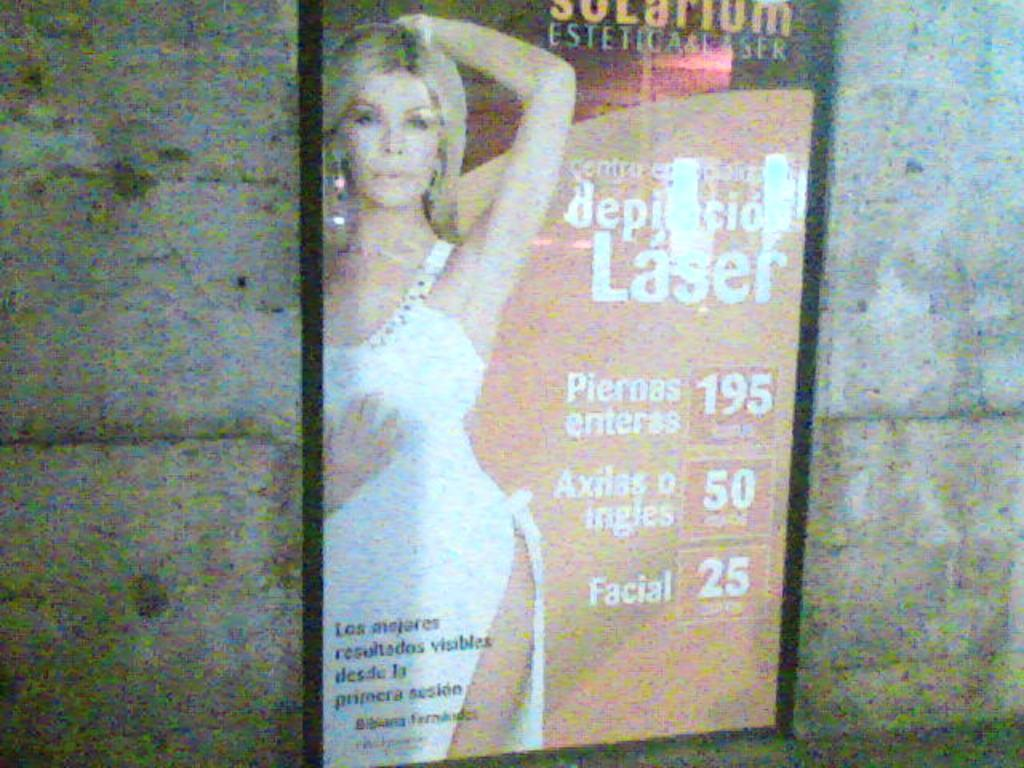What is the main subject in the center of the image? There is a board or banner in the center of the image. What is depicted on the board or banner? The board or banner has a photograph of a woman. Are there any words or phrases on the board or banner? Yes, there is text on the board or banner. What can be seen behind the board or banner? The background of the image is a wall. How would you describe the appearance of the wall? The wall is blurred. How much force is being applied to the sugar in the image? There is no sugar present in the image, and therefore no force is being applied to it. 